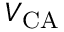<formula> <loc_0><loc_0><loc_500><loc_500>V _ { C A }</formula> 